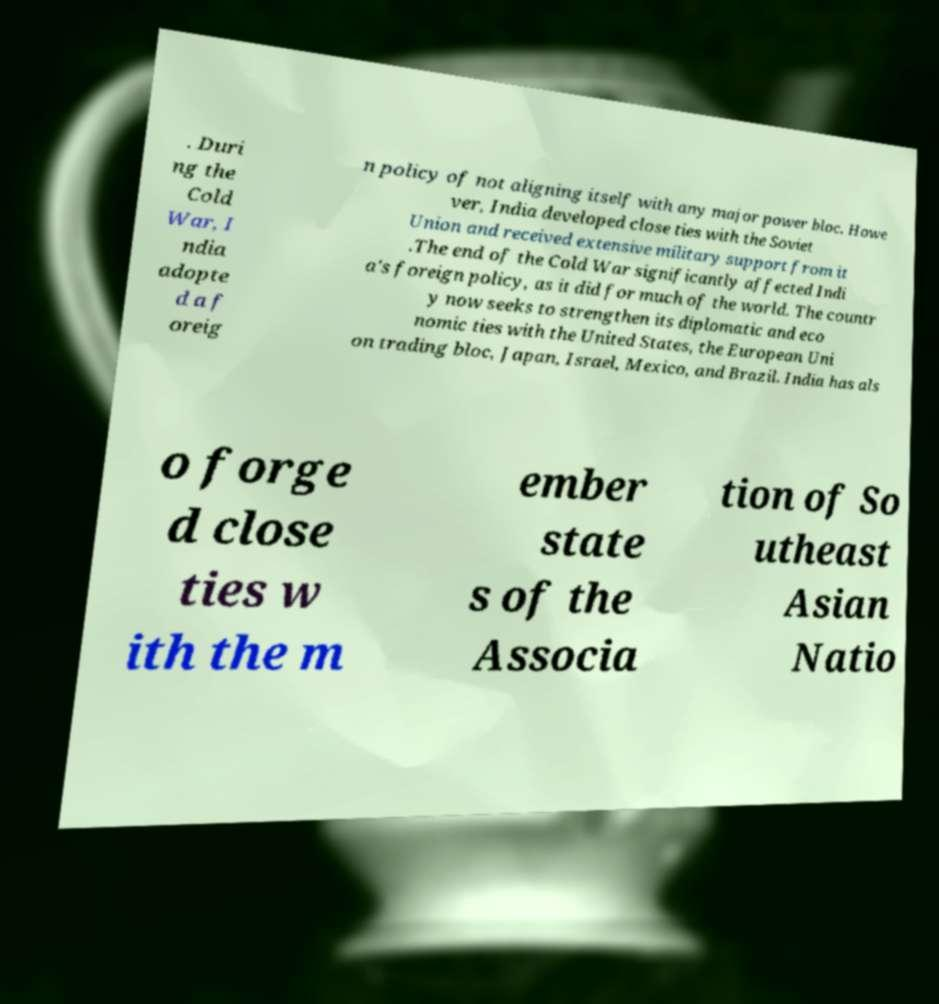I need the written content from this picture converted into text. Can you do that? . Duri ng the Cold War, I ndia adopte d a f oreig n policy of not aligning itself with any major power bloc. Howe ver, India developed close ties with the Soviet Union and received extensive military support from it .The end of the Cold War significantly affected Indi a's foreign policy, as it did for much of the world. The countr y now seeks to strengthen its diplomatic and eco nomic ties with the United States, the European Uni on trading bloc, Japan, Israel, Mexico, and Brazil. India has als o forge d close ties w ith the m ember state s of the Associa tion of So utheast Asian Natio 